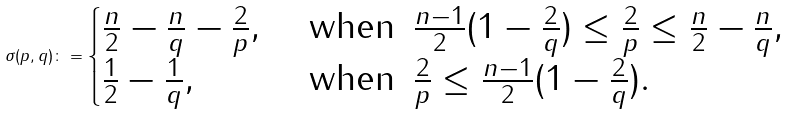<formula> <loc_0><loc_0><loc_500><loc_500>\sigma ( p , q ) \colon = \begin{cases} \frac { n } { 2 } - \frac { n } { q } - \frac { 2 } { p } , & \text { when } \, \frac { n - 1 } { 2 } ( 1 - \frac { 2 } { q } ) \leq \frac { 2 } { p } \leq \frac { n } { 2 } - \frac { n } { q } , \\ \frac { 1 } { 2 } - \frac { 1 } { q } , & \text { when } \, \frac { 2 } { p } \leq \frac { n - 1 } { 2 } ( 1 - \frac { 2 } { q } ) . \end{cases}</formula> 